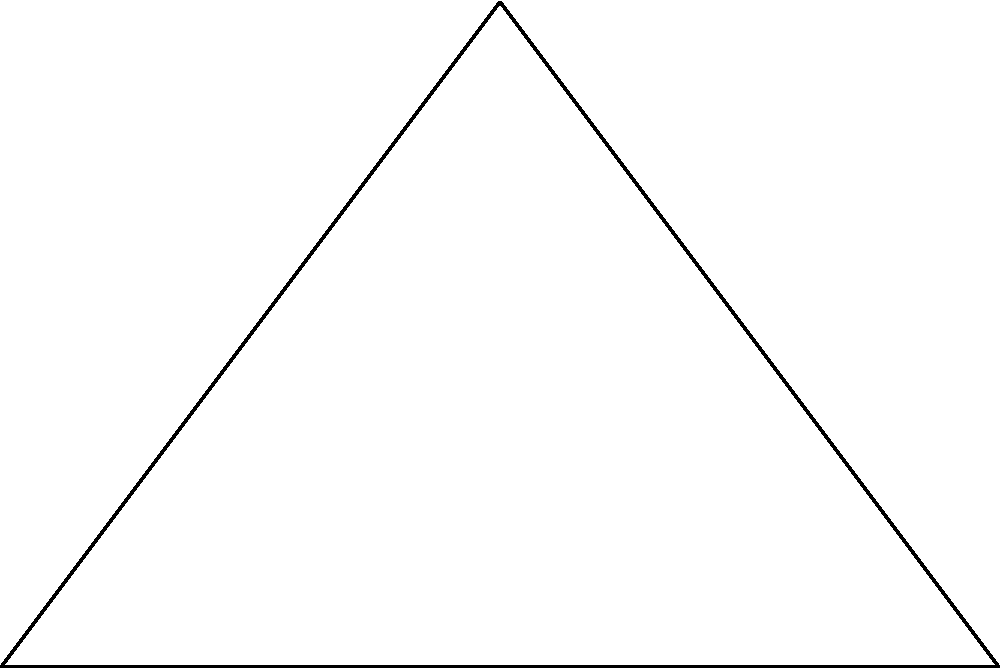In a music score, three notes form a triangle ABC on the staff. The triangle's vertices are at A(0,0), B(6,0), and C(3,4), where each unit represents one staff space. An inscribed circle within this triangle touches all three sides. Calculate the radius of this inscribed circle, representing the size of a perfectly circular note that would fit inside the triangle formed by the three original notes. Let's solve this step-by-step:

1) First, we need to calculate the semi-perimeter of the triangle. The semi-perimeter is half the perimeter.

2) To find the perimeter, we need the lengths of all sides:
   AB = 6
   BC = $\sqrt{(6-3)^2 + (0-4)^2} = \sqrt{9 + 16} = \sqrt{25} = 5$
   CA = $\sqrt{(3-0)^2 + (4-0)^2} = \sqrt{9 + 16} = \sqrt{25} = 5$

3) Perimeter = AB + BC + CA = 6 + 5 + 5 = 16

4) Semi-perimeter (s) = 16/2 = 8

5) Now, we can use the formula for the area of a triangle using semi-perimeter:
   Area = $\sqrt{s(s-a)(s-b)(s-c)}$ where a, b, c are the side lengths

6) Area = $\sqrt{8(8-6)(8-5)(8-5)} = \sqrt{8 \cdot 2 \cdot 3 \cdot 3} = \sqrt{144} = 12$

7) The radius of the inscribed circle is given by the formula:
   $r = \frac{Area}{s} = \frac{12}{8} = 1.5$

Therefore, the radius of the inscribed circle is 1.5 staff spaces.
Answer: 1.5 staff spaces 